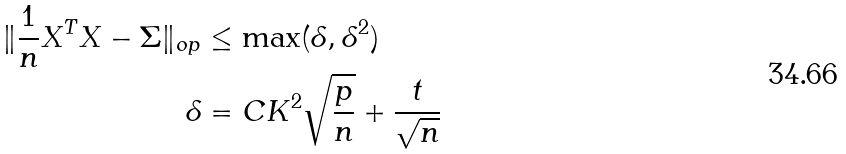Convert formula to latex. <formula><loc_0><loc_0><loc_500><loc_500>\| \frac { 1 } { n } X ^ { T } X - \Sigma \| _ { o p } & \leq \max ( \delta , \delta ^ { 2 } ) \\ \delta & = C K ^ { 2 } \sqrt { \frac { p } { n } } + \frac { t } { \sqrt { n } }</formula> 